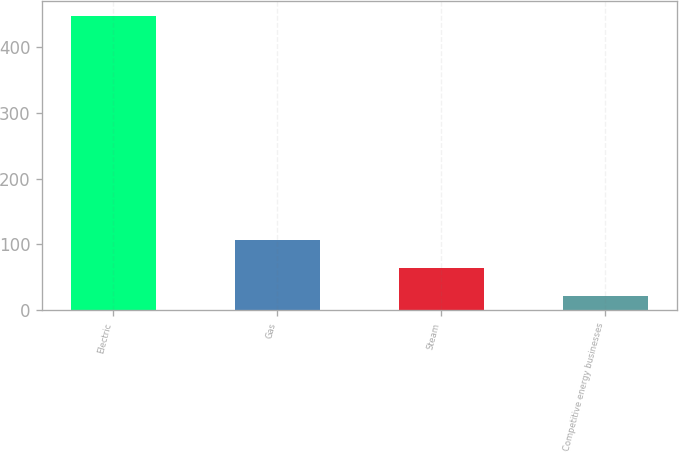<chart> <loc_0><loc_0><loc_500><loc_500><bar_chart><fcel>Electric<fcel>Gas<fcel>Steam<fcel>Competitive energy businesses<nl><fcel>447<fcel>107<fcel>64.5<fcel>22<nl></chart> 